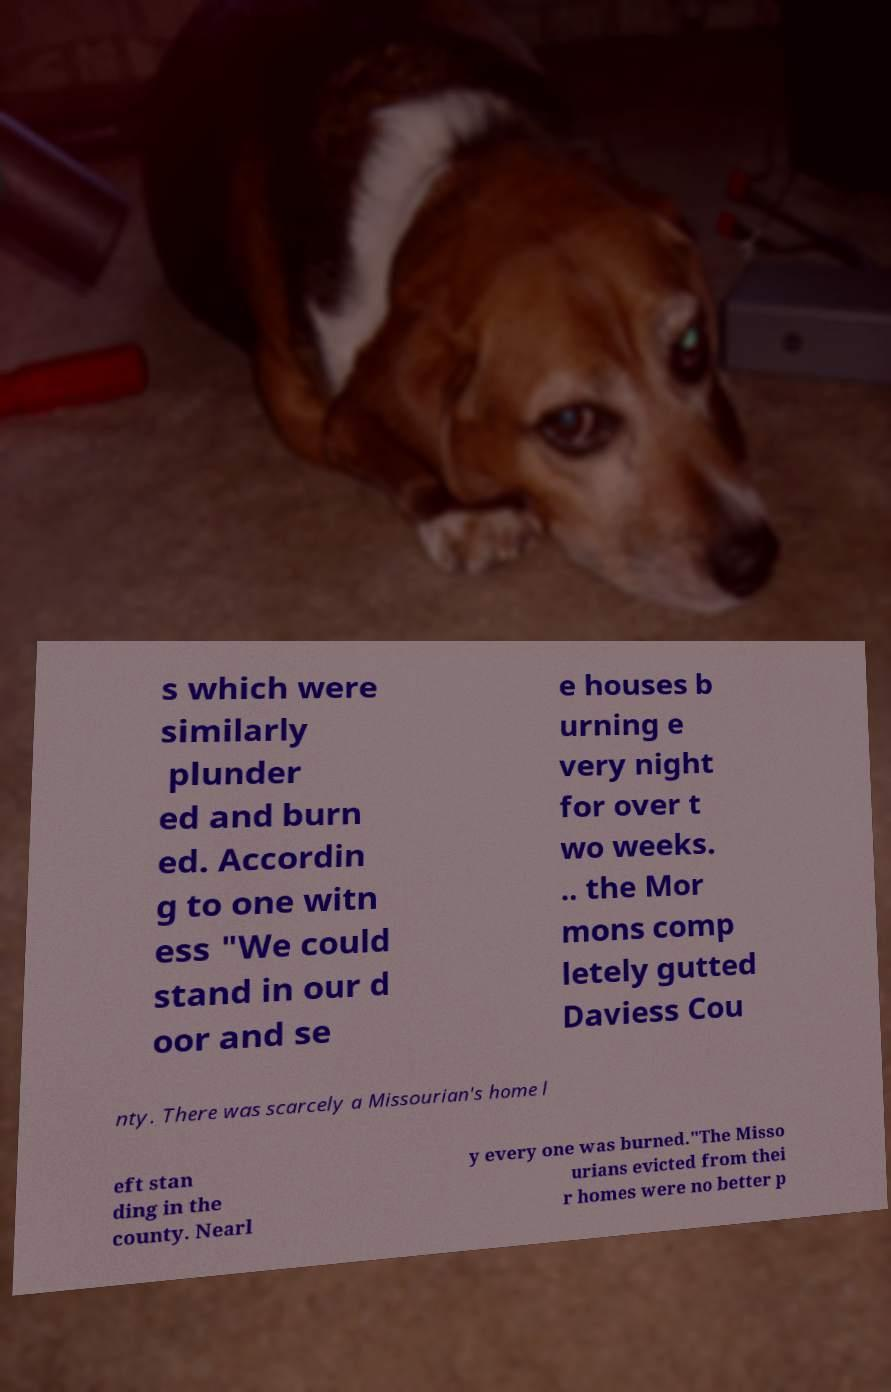Please read and relay the text visible in this image. What does it say? s which were similarly plunder ed and burn ed. Accordin g to one witn ess "We could stand in our d oor and se e houses b urning e very night for over t wo weeks. .. the Mor mons comp letely gutted Daviess Cou nty. There was scarcely a Missourian's home l eft stan ding in the county. Nearl y every one was burned."The Misso urians evicted from thei r homes were no better p 